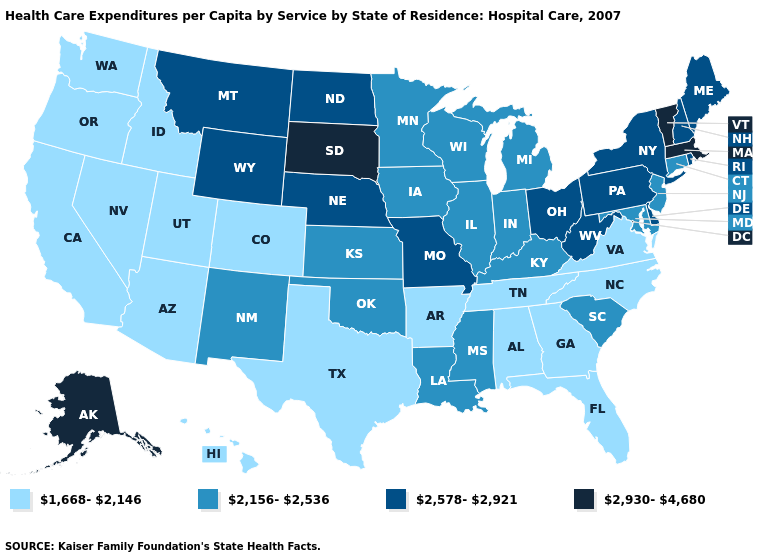Among the states that border Georgia , does South Carolina have the lowest value?
Write a very short answer. No. What is the highest value in the USA?
Concise answer only. 2,930-4,680. Does the first symbol in the legend represent the smallest category?
Be succinct. Yes. Does New Jersey have the lowest value in the Northeast?
Write a very short answer. Yes. Does Illinois have the lowest value in the USA?
Keep it brief. No. What is the lowest value in the USA?
Give a very brief answer. 1,668-2,146. What is the value of Oklahoma?
Keep it brief. 2,156-2,536. What is the value of California?
Concise answer only. 1,668-2,146. Name the states that have a value in the range 1,668-2,146?
Answer briefly. Alabama, Arizona, Arkansas, California, Colorado, Florida, Georgia, Hawaii, Idaho, Nevada, North Carolina, Oregon, Tennessee, Texas, Utah, Virginia, Washington. Name the states that have a value in the range 2,578-2,921?
Give a very brief answer. Delaware, Maine, Missouri, Montana, Nebraska, New Hampshire, New York, North Dakota, Ohio, Pennsylvania, Rhode Island, West Virginia, Wyoming. What is the highest value in the USA?
Be succinct. 2,930-4,680. What is the value of Oklahoma?
Give a very brief answer. 2,156-2,536. Which states have the lowest value in the Northeast?
Be succinct. Connecticut, New Jersey. Name the states that have a value in the range 1,668-2,146?
Keep it brief. Alabama, Arizona, Arkansas, California, Colorado, Florida, Georgia, Hawaii, Idaho, Nevada, North Carolina, Oregon, Tennessee, Texas, Utah, Virginia, Washington. 